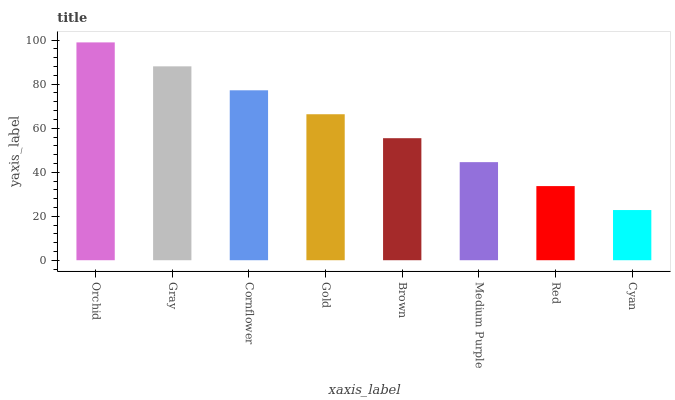Is Cyan the minimum?
Answer yes or no. Yes. Is Orchid the maximum?
Answer yes or no. Yes. Is Gray the minimum?
Answer yes or no. No. Is Gray the maximum?
Answer yes or no. No. Is Orchid greater than Gray?
Answer yes or no. Yes. Is Gray less than Orchid?
Answer yes or no. Yes. Is Gray greater than Orchid?
Answer yes or no. No. Is Orchid less than Gray?
Answer yes or no. No. Is Gold the high median?
Answer yes or no. Yes. Is Brown the low median?
Answer yes or no. Yes. Is Medium Purple the high median?
Answer yes or no. No. Is Cyan the low median?
Answer yes or no. No. 